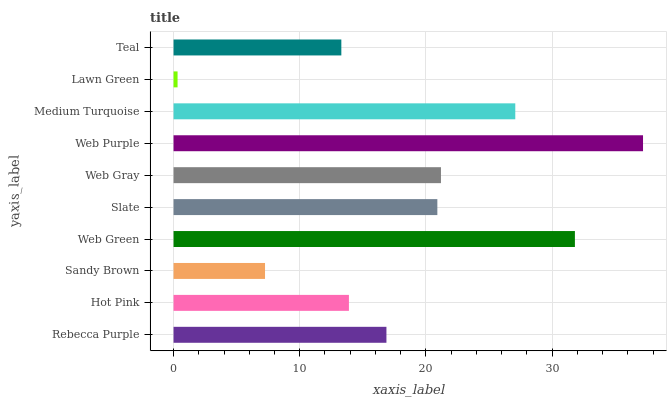Is Lawn Green the minimum?
Answer yes or no. Yes. Is Web Purple the maximum?
Answer yes or no. Yes. Is Hot Pink the minimum?
Answer yes or no. No. Is Hot Pink the maximum?
Answer yes or no. No. Is Rebecca Purple greater than Hot Pink?
Answer yes or no. Yes. Is Hot Pink less than Rebecca Purple?
Answer yes or no. Yes. Is Hot Pink greater than Rebecca Purple?
Answer yes or no. No. Is Rebecca Purple less than Hot Pink?
Answer yes or no. No. Is Slate the high median?
Answer yes or no. Yes. Is Rebecca Purple the low median?
Answer yes or no. Yes. Is Web Green the high median?
Answer yes or no. No. Is Medium Turquoise the low median?
Answer yes or no. No. 